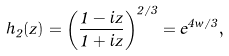Convert formula to latex. <formula><loc_0><loc_0><loc_500><loc_500>h _ { 2 } ( z ) = \left ( \frac { 1 - i z } { 1 + i z } \right ) ^ { 2 / 3 } = e ^ { 4 w / 3 } ,</formula> 